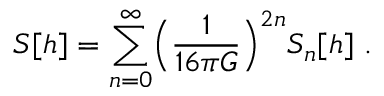<formula> <loc_0><loc_0><loc_500><loc_500>S [ h ] = \sum _ { n = 0 } ^ { \infty } \left ( \frac { 1 } { 1 6 \pi G } \right ) ^ { 2 n } S _ { n } [ h ] \ .</formula> 